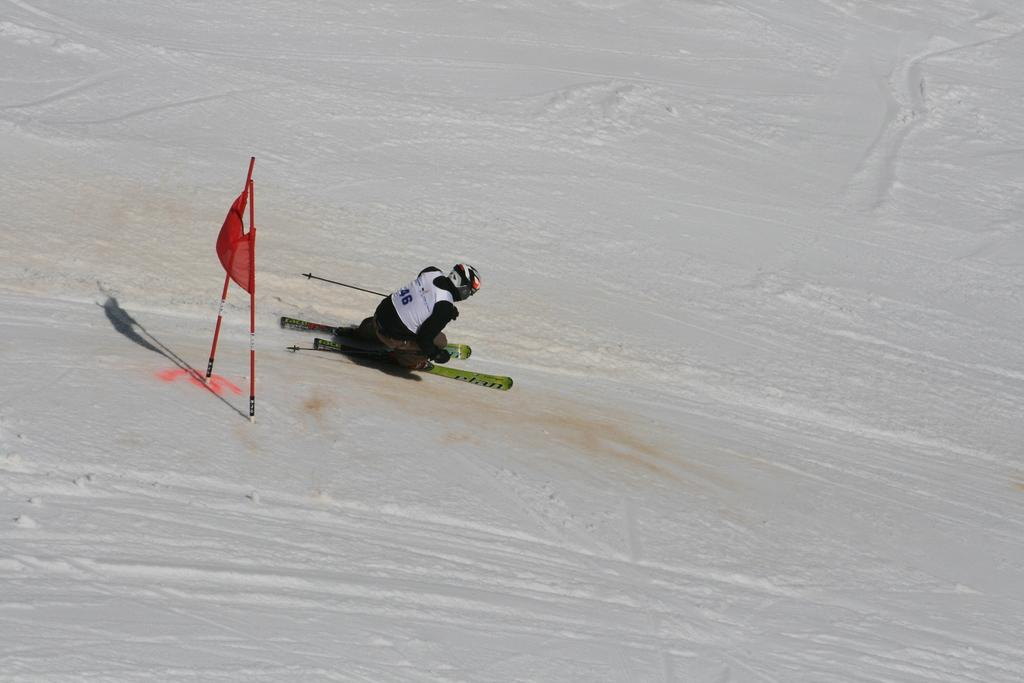What is the person in the image doing? The person is skiing on ice. Where is the flag located in the image? The flag is on the left side of the image. What is the primary surface that the person is skiing on? Ice is present throughout the image, and the person is skiing on it. How many stitches are visible on the person's feet in the image? There are no stitches visible on the person's feet in the image, as they are wearing ski boots. 